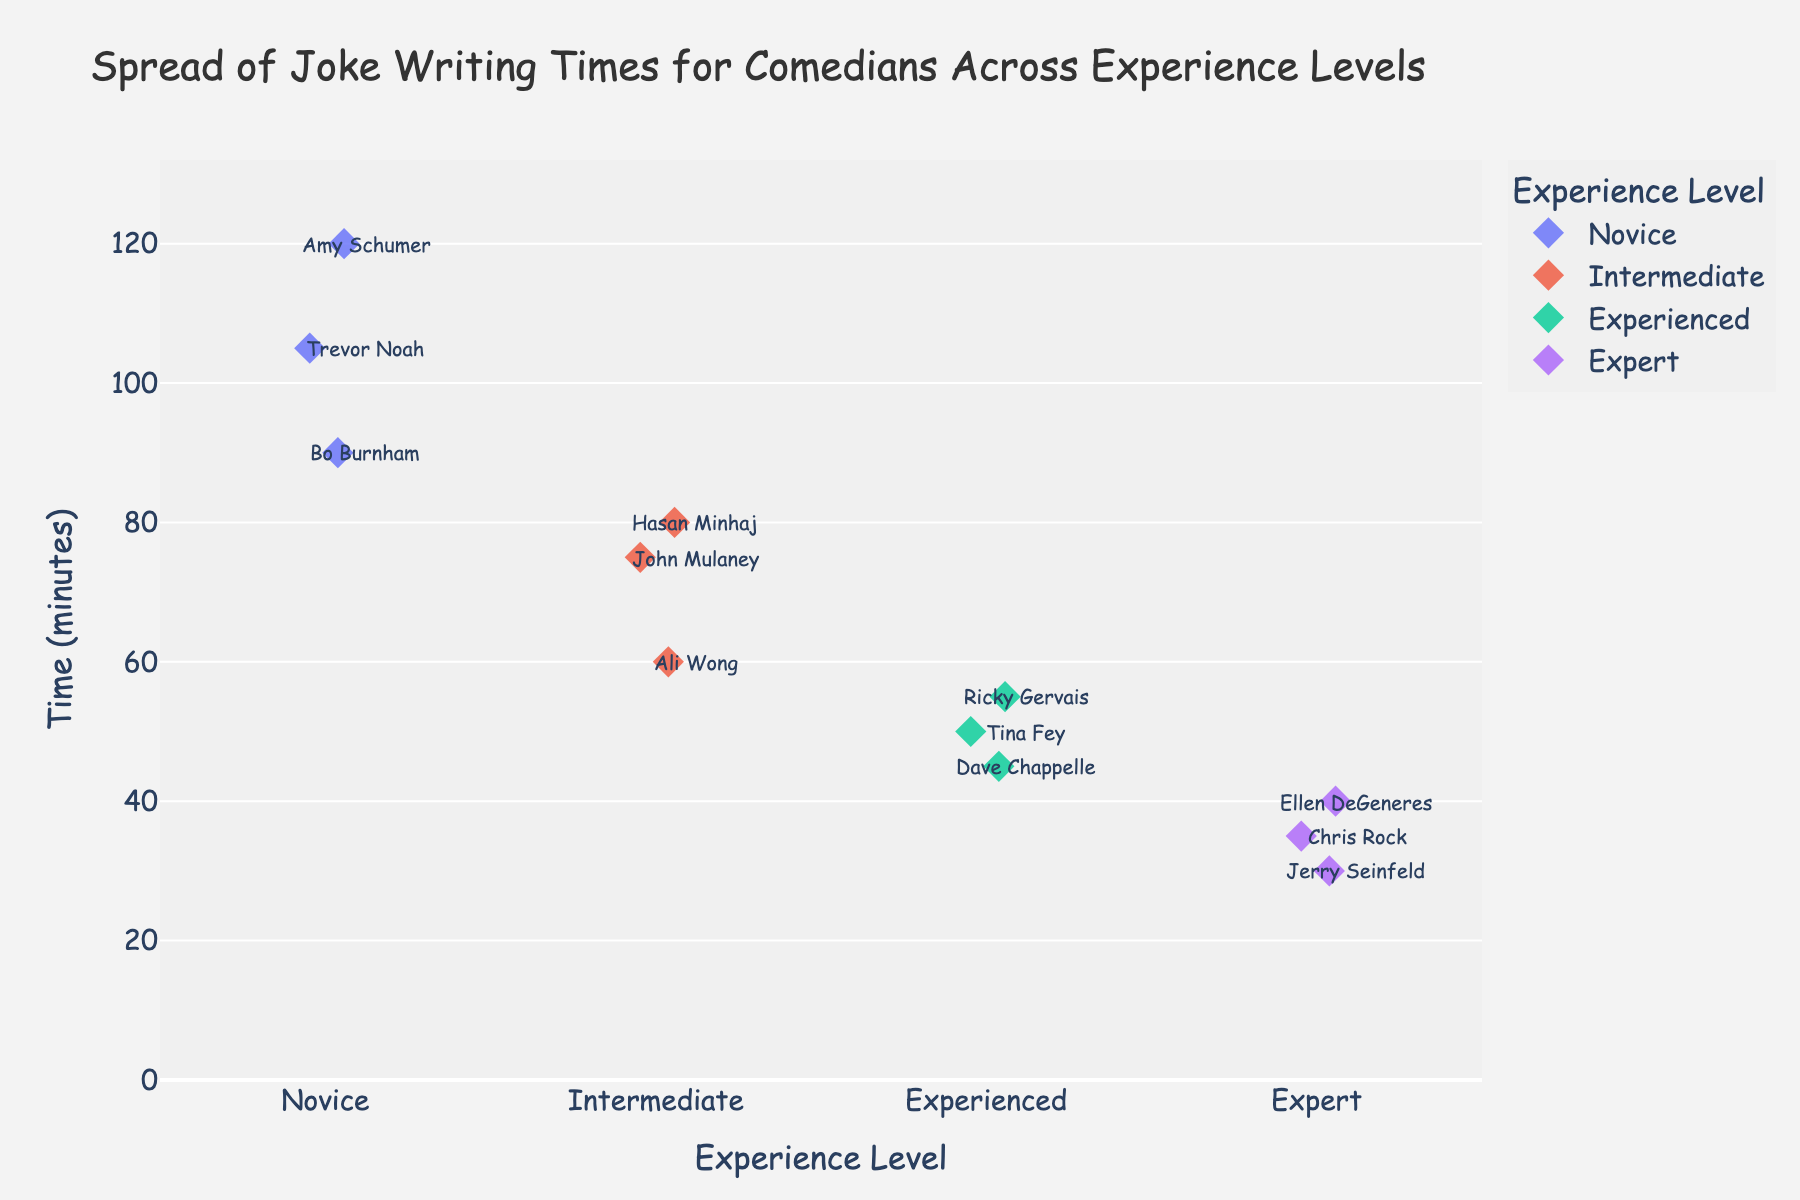Which experience level has the highest average joke writing time? To determine this, we calculate the average joke writing time for each experience level. Novice: (120 + 90 + 105)/3 = 105 minutes; Intermediate: (75 + 60 + 80)/3 = 71.67 minutes; Experienced: (45 + 50 + 55)/3 = 50 minutes; Expert: (30 + 35 + 40)/3 = 35 minutes. Novice has the highest average.
Answer: Novice What's the median joke writing time for the Intermediate experience level? The Intermediate group consists of joke writing times 75, 60, and 80. When ordered, they are 60, 75, and 80. The median is the middle value, which is 75 minutes.
Answer: 75 minutes Who is the comedian with the shortest joke writing time and what is their experience level? By examining the strip plot, we identify the lowest point on the y-axis and check the corresponding comedian and their experience level. Jerry Seinfeld has the shortest time at 30 minutes and he's an Expert.
Answer: Jerry Seinfeld, Expert Compare the spread of joke writing times for Novice and Expert levels. Which level shows more variation? To compare the spread, we look at the range of joke writing times for both levels. Novice: 120 - 90 = 30 minutes; Expert: 40 - 30 = 10 minutes. Novice shows more variation.
Answer: Novice How many comedians are at the Experienced level? The strip plot shows three markers under the Experienced level, indicating there are three comedians.
Answer: 3 comedians Which comedian took 50 minutes to write jokes and what is their experience level? The strip plot annotation shows Tina Fey as the comedian with a joke writing time of 50 minutes, and she is at the Experienced level.
Answer: Tina Fey, Experienced Which experience level has the most clustering of data points around a similar joke writing time? By visual inspection, the Expert level has data points clustered more closely together, all between 30 and 40 minutes.
Answer: Expert What is the difference in joke writing time between the longest and shortest times for all comedians? The longest time is 120 minutes (Amy Schumer) and the shortest is 30 minutes (Jerry Seinfeld). The difference is 120 - 30 = 90 minutes.
Answer: 90 minutes Who are the comedians at the Intermediate level, and what are their joke writing times? From the strip plot annotations, the Intermediate level includes John Mulaney (75 minutes), Ali Wong (60 minutes), and Hasan Minhaj (80 minutes).
Answer: John Mulaney: 75, Ali Wong: 60, Hasan Minhaj: 80 